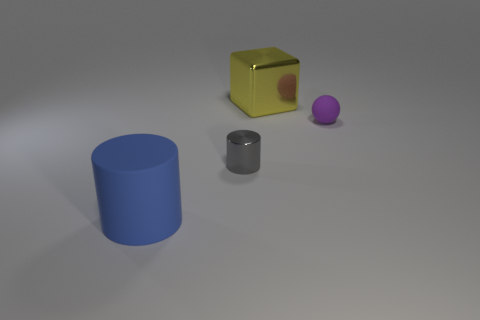Subtract all blue cylinders. How many cylinders are left? 1 Subtract 1 cylinders. How many cylinders are left? 1 Subtract all green balls. Subtract all brown cylinders. How many balls are left? 1 Subtract all purple blocks. How many gray cylinders are left? 1 Subtract all blocks. Subtract all blue cylinders. How many objects are left? 2 Add 4 yellow metal objects. How many yellow metal objects are left? 5 Add 4 green shiny cylinders. How many green shiny cylinders exist? 4 Add 3 metallic blocks. How many objects exist? 7 Subtract 0 cyan spheres. How many objects are left? 4 Subtract all blocks. How many objects are left? 3 